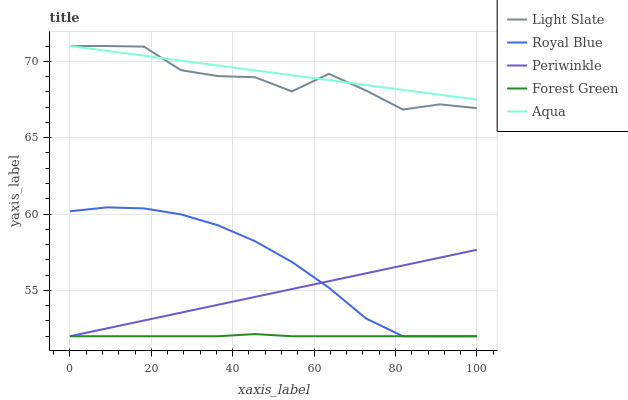Does Forest Green have the minimum area under the curve?
Answer yes or no. Yes. Does Aqua have the maximum area under the curve?
Answer yes or no. Yes. Does Royal Blue have the minimum area under the curve?
Answer yes or no. No. Does Royal Blue have the maximum area under the curve?
Answer yes or no. No. Is Aqua the smoothest?
Answer yes or no. Yes. Is Light Slate the roughest?
Answer yes or no. Yes. Is Royal Blue the smoothest?
Answer yes or no. No. Is Royal Blue the roughest?
Answer yes or no. No. Does Aqua have the lowest value?
Answer yes or no. No. Does Aqua have the highest value?
Answer yes or no. Yes. Does Royal Blue have the highest value?
Answer yes or no. No. Is Forest Green less than Light Slate?
Answer yes or no. Yes. Is Aqua greater than Royal Blue?
Answer yes or no. Yes. Does Aqua intersect Light Slate?
Answer yes or no. Yes. Is Aqua less than Light Slate?
Answer yes or no. No. Is Aqua greater than Light Slate?
Answer yes or no. No. Does Forest Green intersect Light Slate?
Answer yes or no. No. 